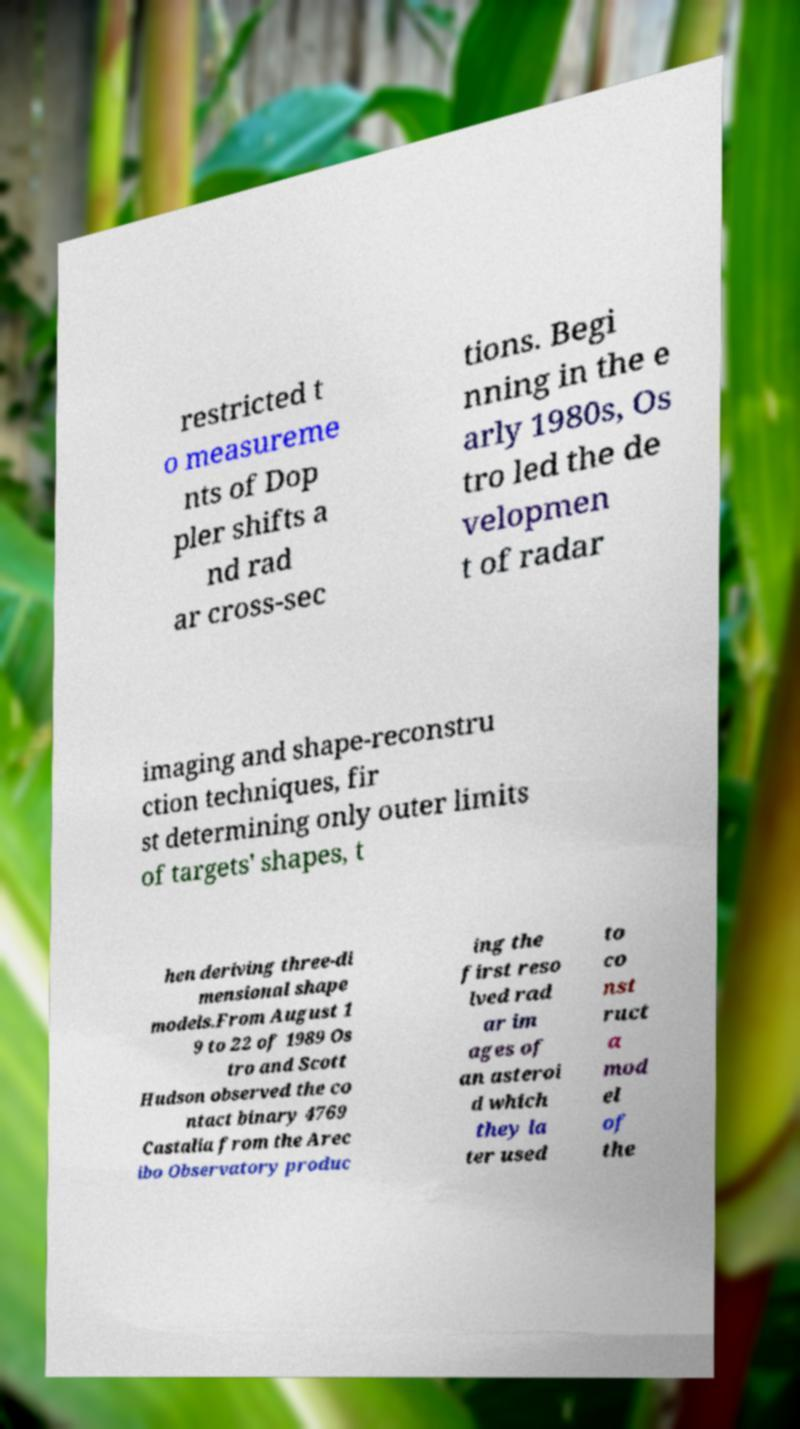There's text embedded in this image that I need extracted. Can you transcribe it verbatim? restricted t o measureme nts of Dop pler shifts a nd rad ar cross-sec tions. Begi nning in the e arly 1980s, Os tro led the de velopmen t of radar imaging and shape-reconstru ction techniques, fir st determining only outer limits of targets' shapes, t hen deriving three-di mensional shape models.From August 1 9 to 22 of 1989 Os tro and Scott Hudson observed the co ntact binary 4769 Castalia from the Arec ibo Observatory produc ing the first reso lved rad ar im ages of an asteroi d which they la ter used to co nst ruct a mod el of the 